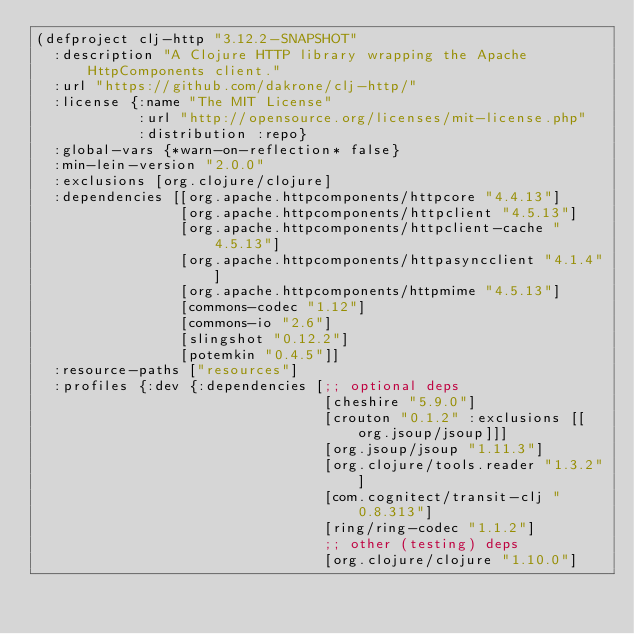Convert code to text. <code><loc_0><loc_0><loc_500><loc_500><_Clojure_>(defproject clj-http "3.12.2-SNAPSHOT"
  :description "A Clojure HTTP library wrapping the Apache HttpComponents client."
  :url "https://github.com/dakrone/clj-http/"
  :license {:name "The MIT License"
            :url "http://opensource.org/licenses/mit-license.php"
            :distribution :repo}
  :global-vars {*warn-on-reflection* false}
  :min-lein-version "2.0.0"
  :exclusions [org.clojure/clojure]
  :dependencies [[org.apache.httpcomponents/httpcore "4.4.13"]
                 [org.apache.httpcomponents/httpclient "4.5.13"]
                 [org.apache.httpcomponents/httpclient-cache "4.5.13"]
                 [org.apache.httpcomponents/httpasyncclient "4.1.4"]
                 [org.apache.httpcomponents/httpmime "4.5.13"]
                 [commons-codec "1.12"]
                 [commons-io "2.6"]
                 [slingshot "0.12.2"]
                 [potemkin "0.4.5"]]
  :resource-paths ["resources"]
  :profiles {:dev {:dependencies [;; optional deps
                                  [cheshire "5.9.0"]
                                  [crouton "0.1.2" :exclusions [[org.jsoup/jsoup]]]
                                  [org.jsoup/jsoup "1.11.3"]
                                  [org.clojure/tools.reader "1.3.2"]
                                  [com.cognitect/transit-clj "0.8.313"]
                                  [ring/ring-codec "1.1.2"]
                                  ;; other (testing) deps
                                  [org.clojure/clojure "1.10.0"]</code> 